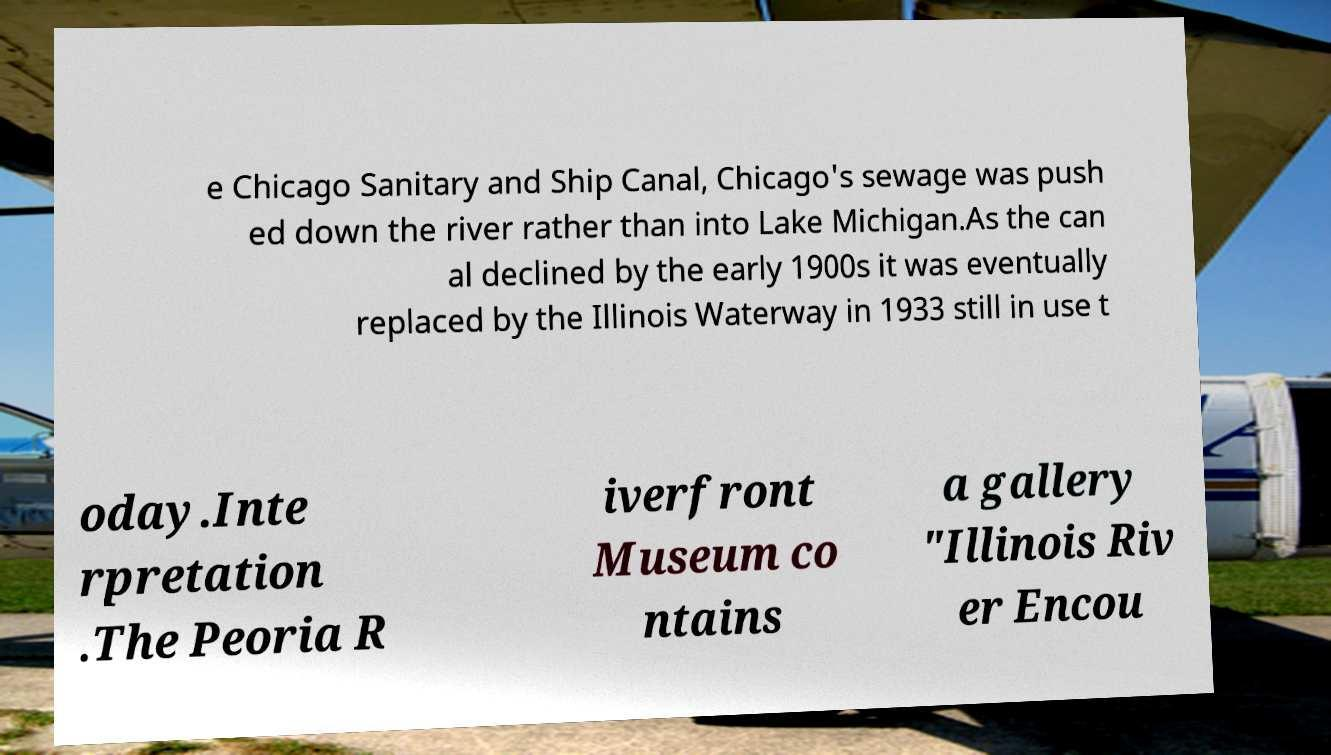Could you extract and type out the text from this image? e Chicago Sanitary and Ship Canal, Chicago's sewage was push ed down the river rather than into Lake Michigan.As the can al declined by the early 1900s it was eventually replaced by the Illinois Waterway in 1933 still in use t oday.Inte rpretation .The Peoria R iverfront Museum co ntains a gallery "Illinois Riv er Encou 